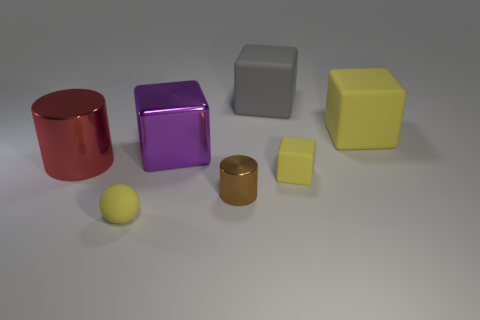Add 1 tiny red blocks. How many objects exist? 8 Subtract all spheres. How many objects are left? 6 Add 2 big metallic cubes. How many big metallic cubes exist? 3 Subtract 0 gray cylinders. How many objects are left? 7 Subtract all rubber balls. Subtract all small brown cylinders. How many objects are left? 5 Add 5 big cylinders. How many big cylinders are left? 6 